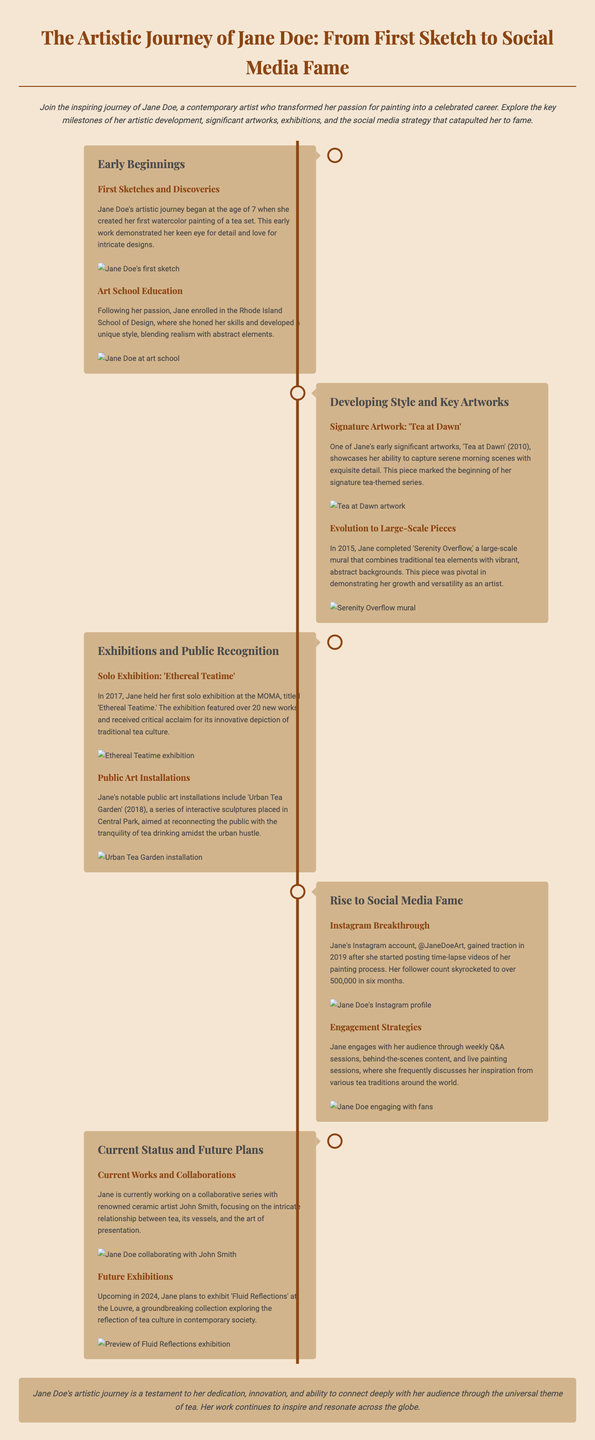What age did Jane Doe start painting? Jane Doe began her artistic journey at the age of 7.
Answer: 7 What is the title of Jane's signature artwork? Jane's signature artwork is titled 'Tea at Dawn'.
Answer: Tea at Dawn In which year did Jane hold her first solo exhibition? Jane's first solo exhibition took place in 2017.
Answer: 2017 How many followers did Jane gain within six months on Instagram? Jane's follower count skyrocketed to over 500,000 in six months.
Answer: 500,000 What is the name of the collaborative series Jane is currently working on? Jane is currently collaborating on a series focusing on tea vessels and presentation.
Answer: tea vessels and presentation What was the title of Jane's large-scale mural completed in 2015? The title of the large-scale mural is 'Serenity Overflow'.
Answer: Serenity Overflow How many works were featured in the 'Ethereal Teatime' exhibition? The exhibition featured over 20 new works.
Answer: over 20 What social media platform did Jane gain recognition on? Jane gained recognition on Instagram.
Answer: Instagram What will be the title of Jane's upcoming exhibition in 2024? The title of the upcoming exhibition is 'Fluid Reflections'.
Answer: Fluid Reflections 